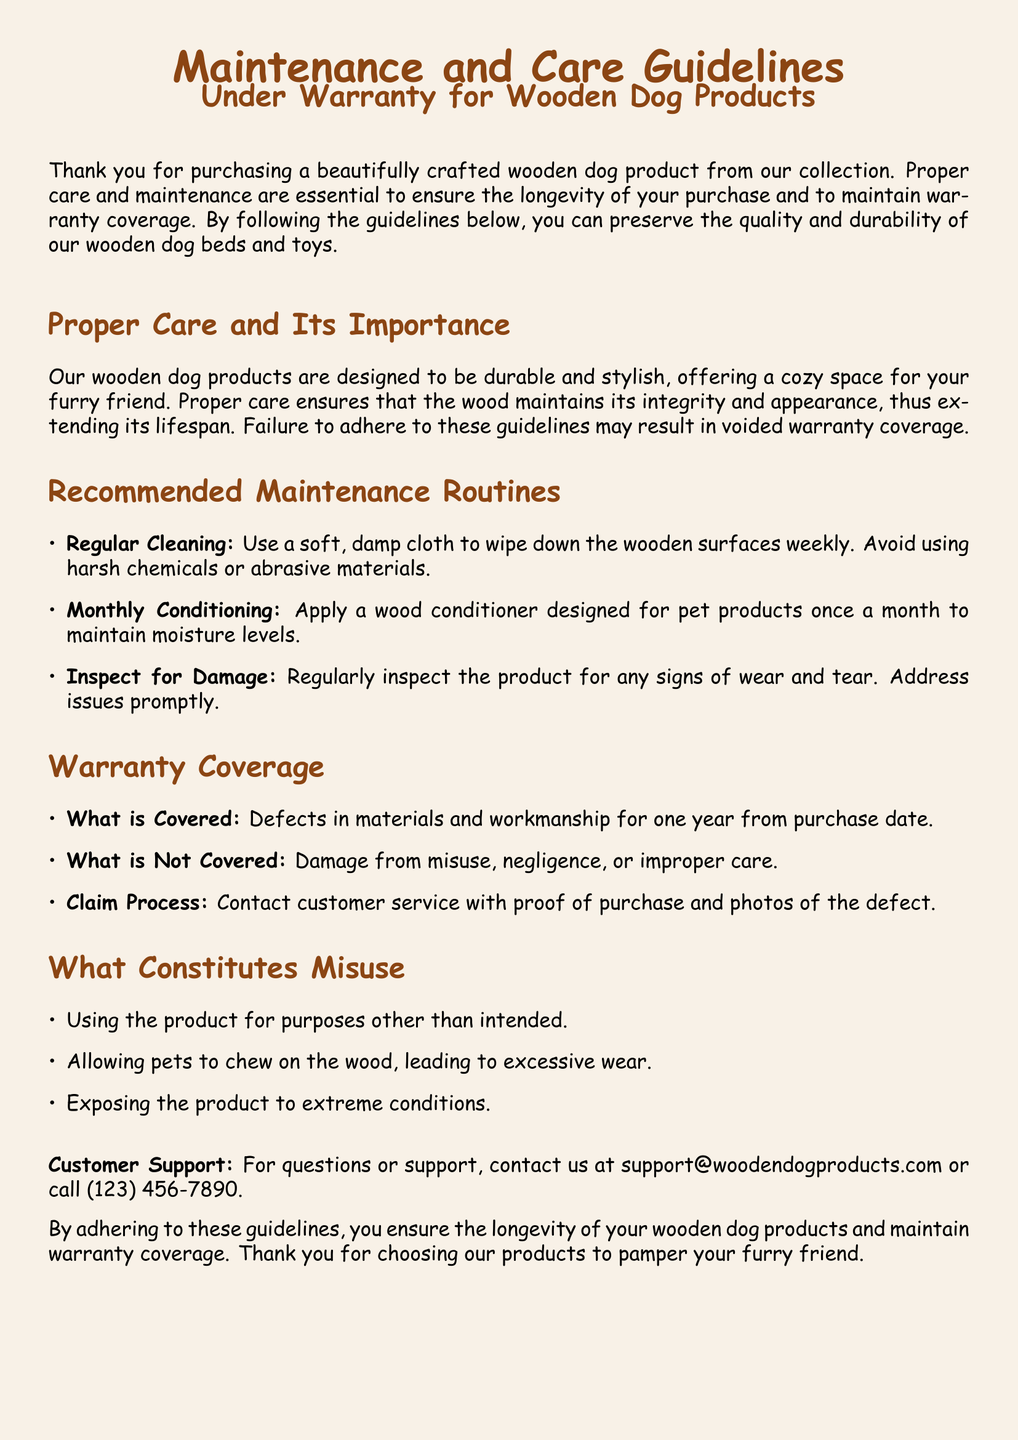what is the warranty coverage period? The warranty covers defects in materials and workmanship for one year from the purchase date.
Answer: one year what is recommended for monthly maintenance? The document advises to apply a wood conditioner designed for pet products once a month.
Answer: wood conditioner what can void the warranty? The warranty may be voided due to damage from misuse, negligence, or improper care.
Answer: misuse how often should the wooden surfaces be cleaned? The document suggests cleaning the wooden surfaces weekly with a soft, damp cloth.
Answer: weekly what should be done if signs of wear and tear are found? The document states that issues should be addressed promptly when signs of wear and tear are found.
Answer: address promptly what type of cloth is recommended for cleaning? A soft, damp cloth is recommended for cleaning the wooden surfaces.
Answer: soft, damp cloth what is the purpose of the wood conditioner? The wood conditioner is designed to maintain moisture levels in wooden dog products.
Answer: maintain moisture levels what constitutes misuse of the product? Misuse includes using the product for purposes other than intended and allowing pets to chew on the wood.
Answer: purposes other than intended what is the contact method for customer support? For support, customers can contact through email or phone as listed in the document.
Answer: email or phone 